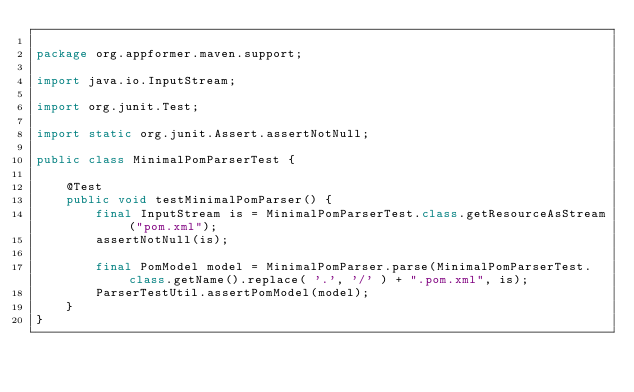Convert code to text. <code><loc_0><loc_0><loc_500><loc_500><_Java_>
package org.appformer.maven.support;

import java.io.InputStream;

import org.junit.Test;

import static org.junit.Assert.assertNotNull;

public class MinimalPomParserTest {

    @Test
    public void testMinimalPomParser() {
        final InputStream is = MinimalPomParserTest.class.getResourceAsStream("pom.xml");
        assertNotNull(is);

        final PomModel model = MinimalPomParser.parse(MinimalPomParserTest.class.getName().replace( '.', '/' ) + ".pom.xml", is);
        ParserTestUtil.assertPomModel(model);
    }
}
</code> 